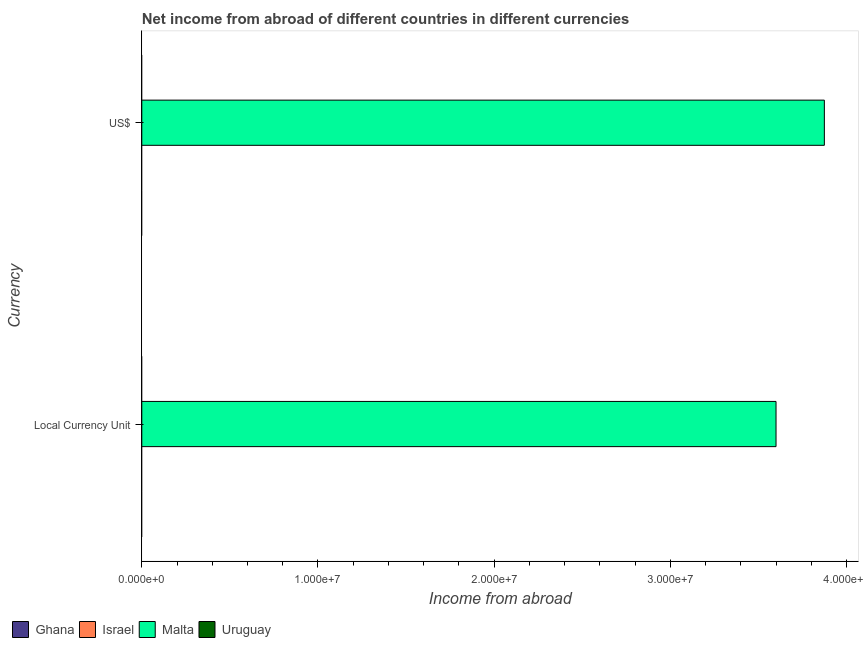How many bars are there on the 1st tick from the top?
Give a very brief answer. 1. What is the label of the 1st group of bars from the top?
Ensure brevity in your answer.  US$. Across all countries, what is the maximum income from abroad in us$?
Your answer should be very brief. 3.87e+07. In which country was the income from abroad in constant 2005 us$ maximum?
Your response must be concise. Malta. What is the total income from abroad in constant 2005 us$ in the graph?
Provide a succinct answer. 3.60e+07. What is the difference between the income from abroad in us$ in Malta and the income from abroad in constant 2005 us$ in Israel?
Ensure brevity in your answer.  3.87e+07. What is the average income from abroad in us$ per country?
Your response must be concise. 9.69e+06. What is the difference between the income from abroad in constant 2005 us$ and income from abroad in us$ in Malta?
Ensure brevity in your answer.  -2.74e+06. In how many countries, is the income from abroad in us$ greater than 32000000 units?
Offer a terse response. 1. How many bars are there?
Give a very brief answer. 2. Are all the bars in the graph horizontal?
Ensure brevity in your answer.  Yes. What is the difference between two consecutive major ticks on the X-axis?
Offer a very short reply. 1.00e+07. Are the values on the major ticks of X-axis written in scientific E-notation?
Provide a succinct answer. Yes. Does the graph contain any zero values?
Keep it short and to the point. Yes. Where does the legend appear in the graph?
Ensure brevity in your answer.  Bottom left. What is the title of the graph?
Give a very brief answer. Net income from abroad of different countries in different currencies. Does "Middle East & North Africa (all income levels)" appear as one of the legend labels in the graph?
Offer a terse response. No. What is the label or title of the X-axis?
Ensure brevity in your answer.  Income from abroad. What is the label or title of the Y-axis?
Ensure brevity in your answer.  Currency. What is the Income from abroad in Israel in Local Currency Unit?
Keep it short and to the point. 0. What is the Income from abroad of Malta in Local Currency Unit?
Offer a terse response. 3.60e+07. What is the Income from abroad of Uruguay in Local Currency Unit?
Make the answer very short. 0. What is the Income from abroad in Ghana in US$?
Provide a short and direct response. 0. What is the Income from abroad in Malta in US$?
Your response must be concise. 3.87e+07. What is the Income from abroad of Uruguay in US$?
Keep it short and to the point. 0. Across all Currency, what is the maximum Income from abroad of Malta?
Your answer should be very brief. 3.87e+07. Across all Currency, what is the minimum Income from abroad of Malta?
Make the answer very short. 3.60e+07. What is the total Income from abroad in Israel in the graph?
Give a very brief answer. 0. What is the total Income from abroad of Malta in the graph?
Your answer should be compact. 7.47e+07. What is the total Income from abroad in Uruguay in the graph?
Your response must be concise. 0. What is the difference between the Income from abroad of Malta in Local Currency Unit and that in US$?
Provide a short and direct response. -2.74e+06. What is the average Income from abroad of Ghana per Currency?
Keep it short and to the point. 0. What is the average Income from abroad in Malta per Currency?
Your response must be concise. 3.74e+07. What is the ratio of the Income from abroad in Malta in Local Currency Unit to that in US$?
Your response must be concise. 0.93. What is the difference between the highest and the second highest Income from abroad of Malta?
Offer a very short reply. 2.74e+06. What is the difference between the highest and the lowest Income from abroad in Malta?
Offer a terse response. 2.74e+06. 